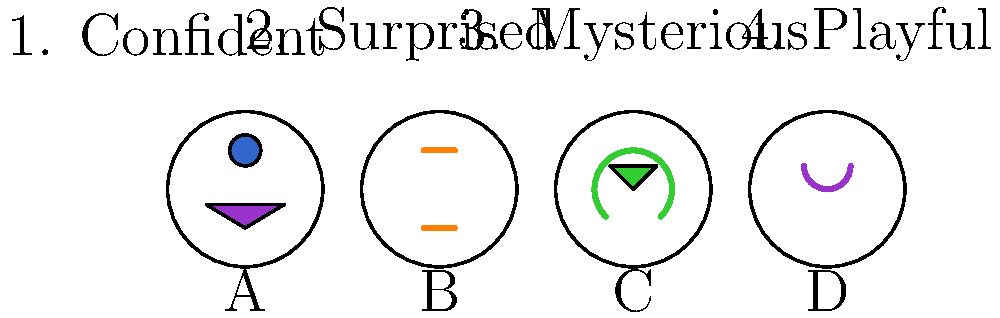Match each unconventional makeup look (A-D) with the most appropriate emotional expression (1-4) it represents. How does this alignment challenge traditional beauty standards? To answer this question, we need to analyze each makeup look and its potential emotional representation:

1. Look A: Features a blue circle on the forehead and a purple triangle on the lower face. This bold, geometric design suggests confidence and assertiveness. It challenges traditional beauty standards by using unconventional shapes and placements.

2. Look B: Has two orange horizontal lines, one above and one below the eyes. This minimalist design evokes a sense of surprise or alertness. It defies conventional makeup by focusing on simple, striking elements rather than enhancing natural features.

3. Look C: Displays a green inverted triangle above the eyes and a green smile-like curve below. This playful, almost whimsical design suggests a lighthearted, fun-loving emotion. It breaks beauty norms by using unexpected colors and shapes to create a cheerful expression.

4. Look D: Shows two curved purple lines framing the eyes and cheeks. This subtle yet striking design creates an air of mystery and intrigue. It challenges traditional makeup by emphasizing the eyes in an unconventional manner.

Matching these looks to the given emotions:
A - 1. Confident
B - 2. Surprised
C - 4. Playful
D - 3. Mysterious

This alignment challenges traditional beauty standards by:
1. Using unconventional colors and shapes
2. Placing makeup in unexpected areas of the face
3. Focusing on emotional expression rather than "perfecting" features
4. Encouraging individual creativity and self-expression through makeup
Answer: A-1, B-2, C-4, D-3 